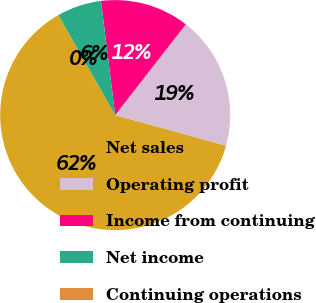Convert chart to OTSL. <chart><loc_0><loc_0><loc_500><loc_500><pie_chart><fcel>Net sales<fcel>Operating profit<fcel>Income from continuing<fcel>Net income<fcel>Continuing operations<nl><fcel>62.5%<fcel>18.75%<fcel>12.5%<fcel>6.25%<fcel>0.0%<nl></chart> 